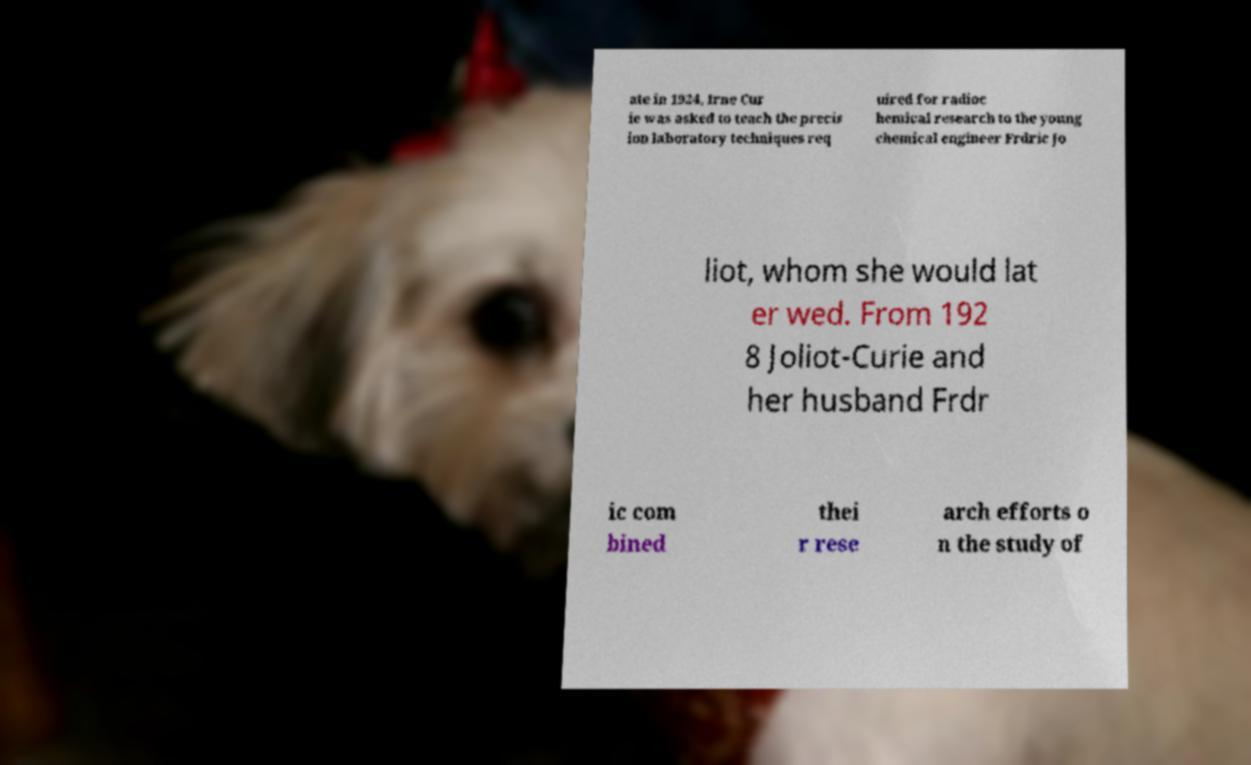Please read and relay the text visible in this image. What does it say? ate in 1924, Irne Cur ie was asked to teach the precis ion laboratory techniques req uired for radioc hemical research to the young chemical engineer Frdric Jo liot, whom she would lat er wed. From 192 8 Joliot-Curie and her husband Frdr ic com bined thei r rese arch efforts o n the study of 